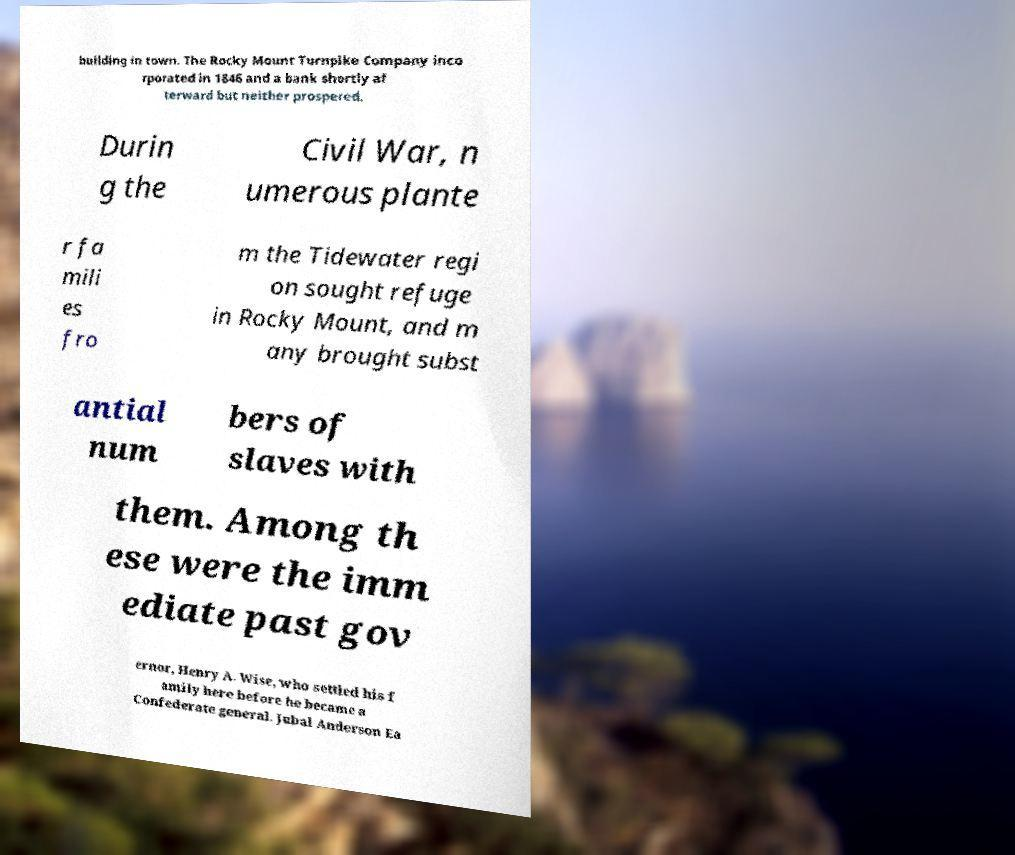Please identify and transcribe the text found in this image. building in town. The Rocky Mount Turnpike Company inco rporated in 1846 and a bank shortly af terward but neither prospered. Durin g the Civil War, n umerous plante r fa mili es fro m the Tidewater regi on sought refuge in Rocky Mount, and m any brought subst antial num bers of slaves with them. Among th ese were the imm ediate past gov ernor, Henry A. Wise, who settled his f amily here before he became a Confederate general. Jubal Anderson Ea 